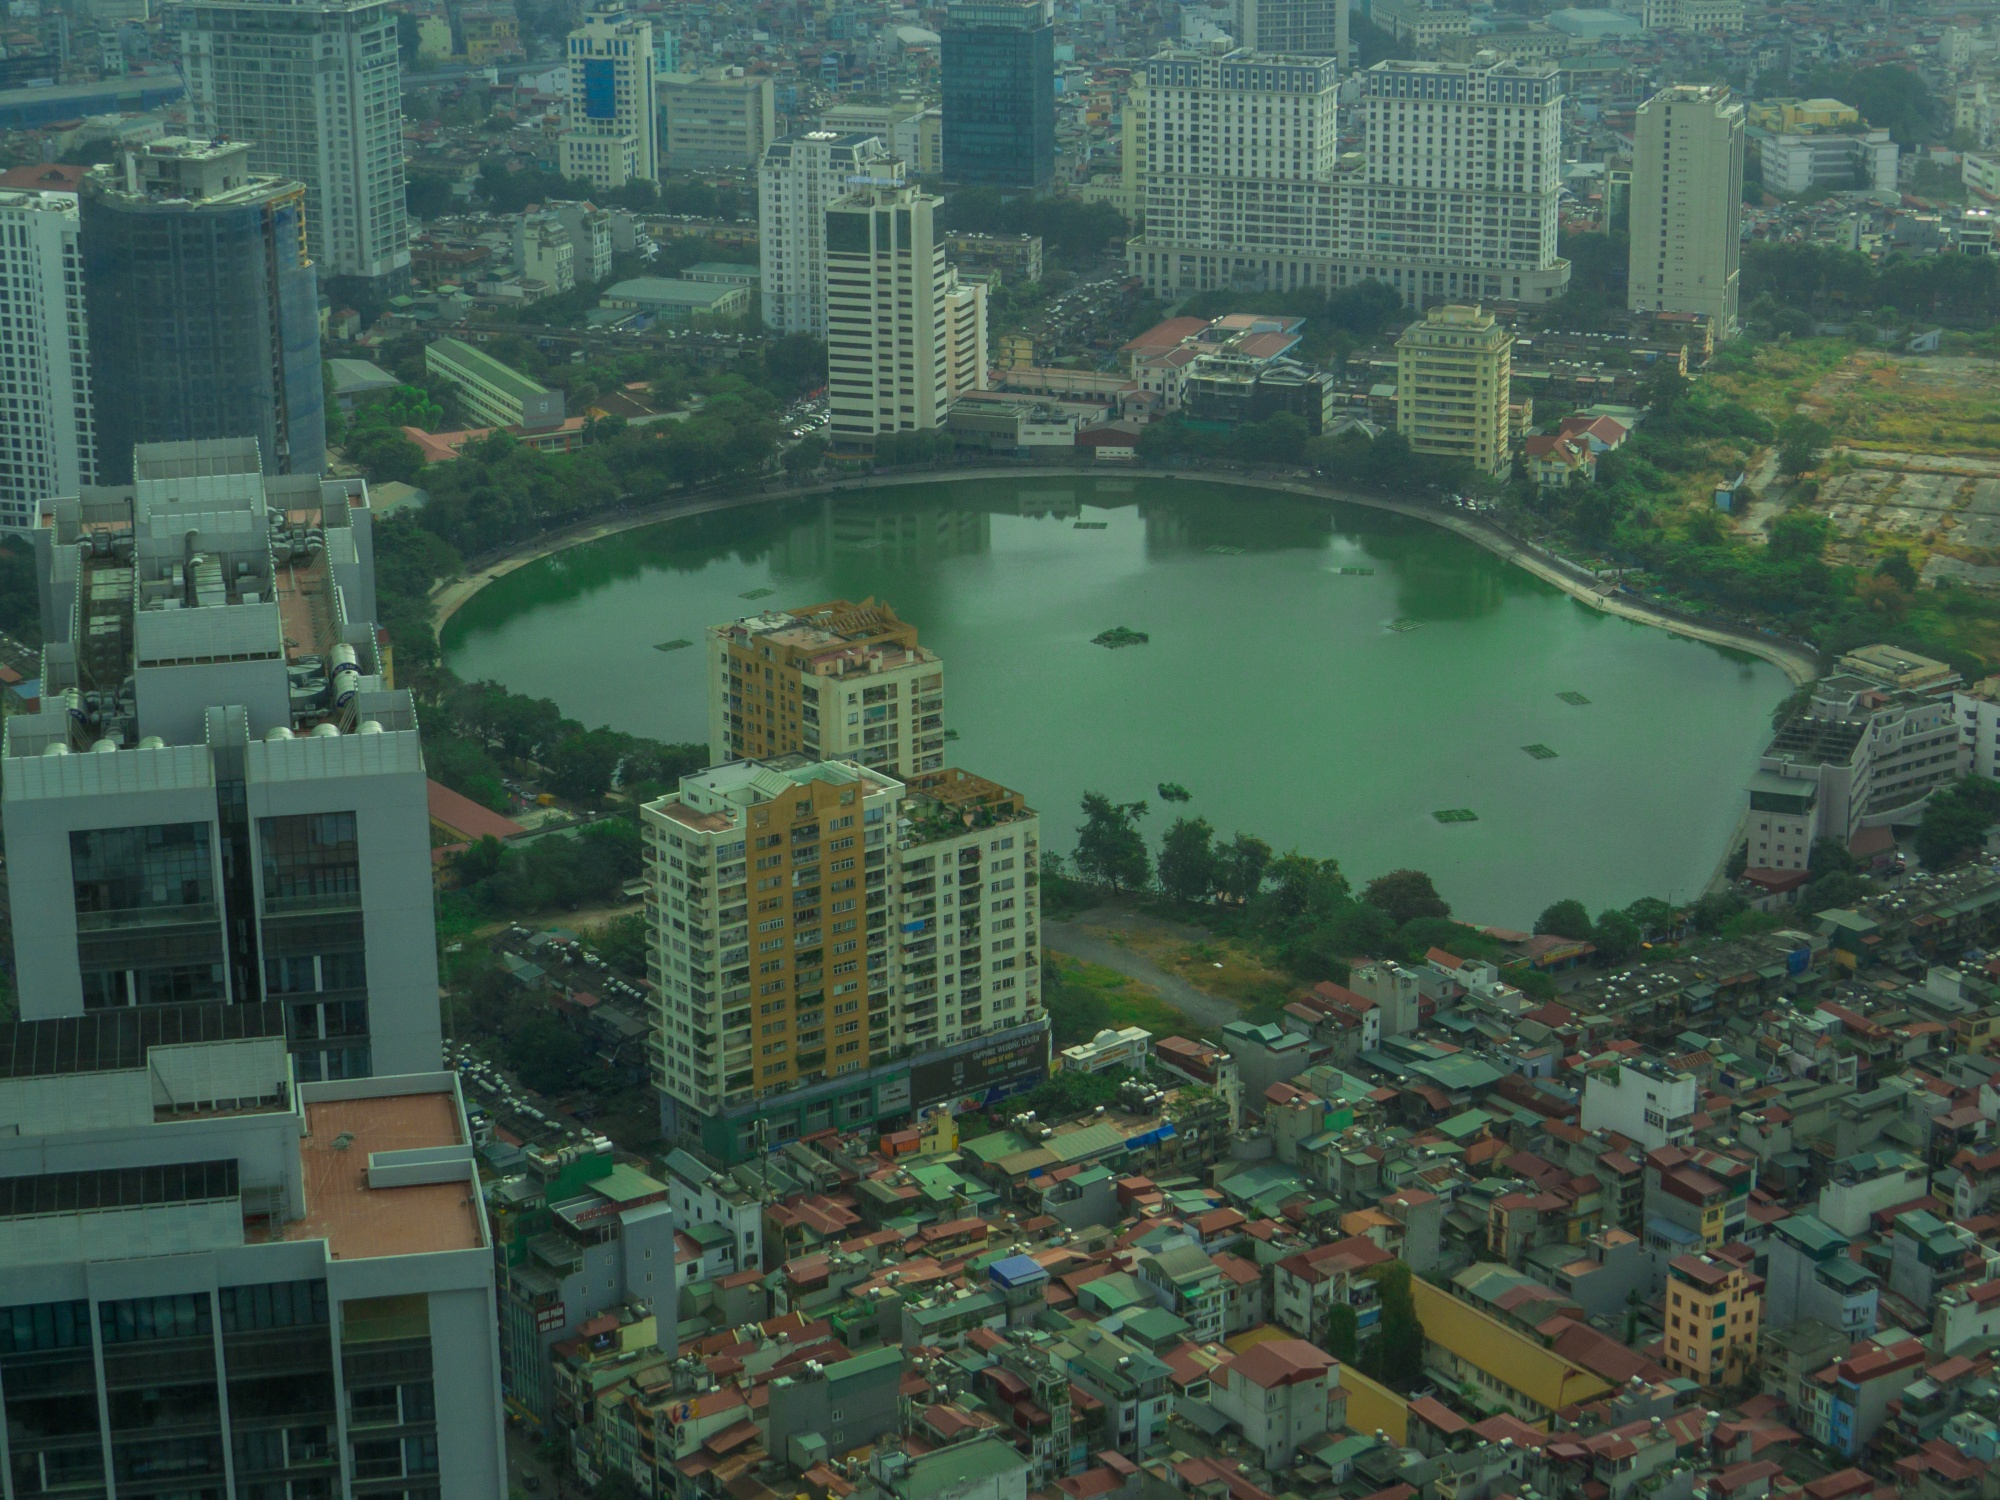Imagine an unusually foggy day over this lake. Describe how the scenery changes and what atmosphere it creates. On an unusually foggy day, the entire landscape around the lake transforms dramatically. A thick blanket of fog envelopes the city, muting the vibrant colors of the buildings and casting a serene, almost ethereal atmosphere over the area. The modern skyscrapers and smaller structures become ghostly silhouettes, emerging faintly through the fog. The lake itself appears mystical, with its surface barely distinguishable under the shroud. The usual reflections of the skyline and sky are softened, creating an illusion of endless depth. Sounds are muffled, and the hustle and bustle of the city feel distant, replaced by a soothing silence. People walking along the lakeside path seem to move through a dreamlike realm, with figures appearing and disappearing in the mist. It's a time when the city feels introspective, as if pausing to reflect under the cloaking veil of fog, transforming the familiar into the beautifully surreal. What legends or myths might local folklore have about this lake on such foggy days? Local folklore might tell of ancient spirits emerging from the fog to wander the lakeshore, guarding hidden treasures submerged beneath the waters. It is said that on foggy days, the boundary between the living and the spirit world blurs, and ethereal figures from the past can be seen gliding across the water’s surface, reenacting scenes long forgotten by time. Another legend speaks of a wise old fisherman who appears only during the fog, offering cryptic advice and prophecies to those who dare to seek him. Children might be told tales of magical creatures such as water sprites or dragonflies that dance in the mist, bringing good luck to those who catch a glimpse. These myths and legends add a dimension of mystery and wonder to the lake, enriching its cultural narrative. 